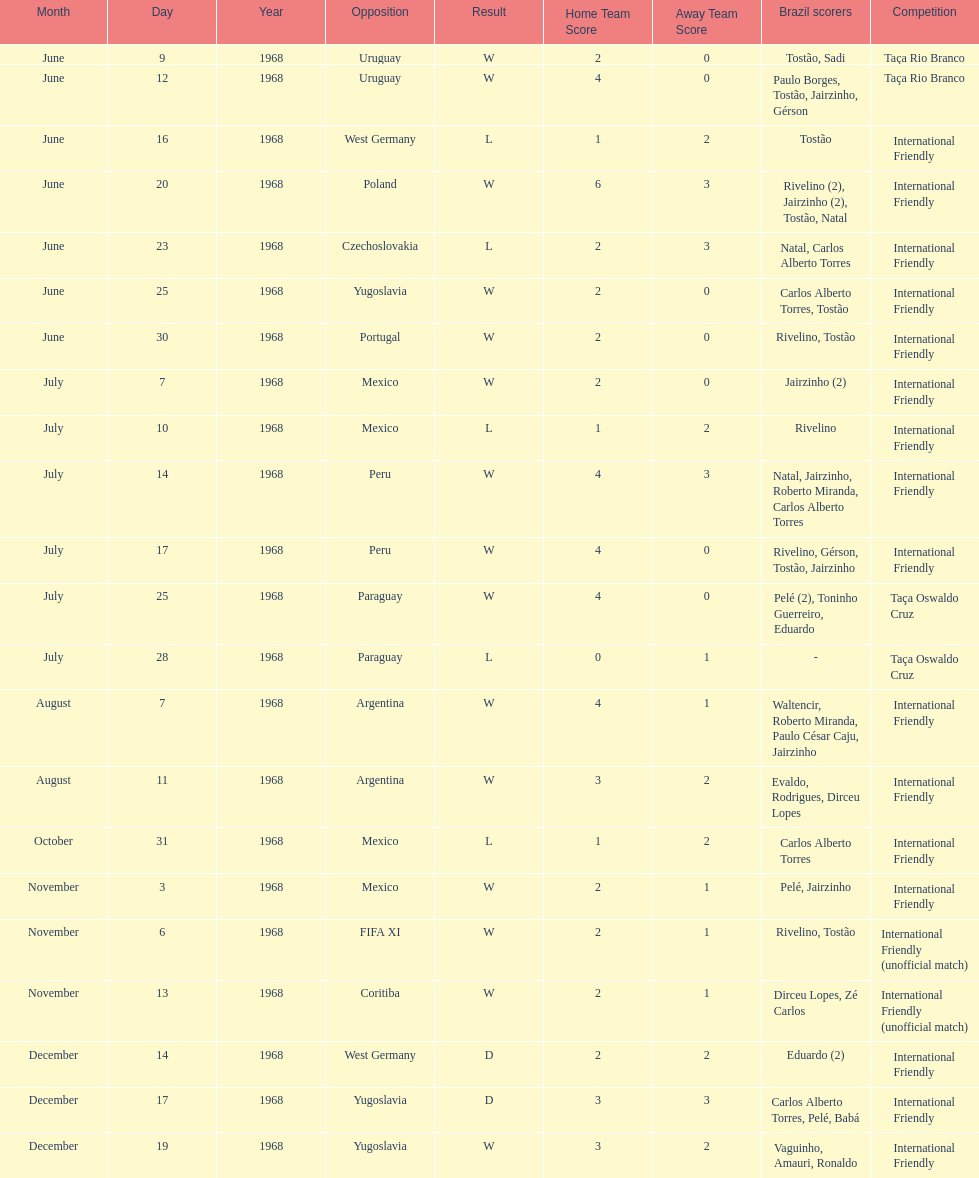How many matches are wins? 15. 